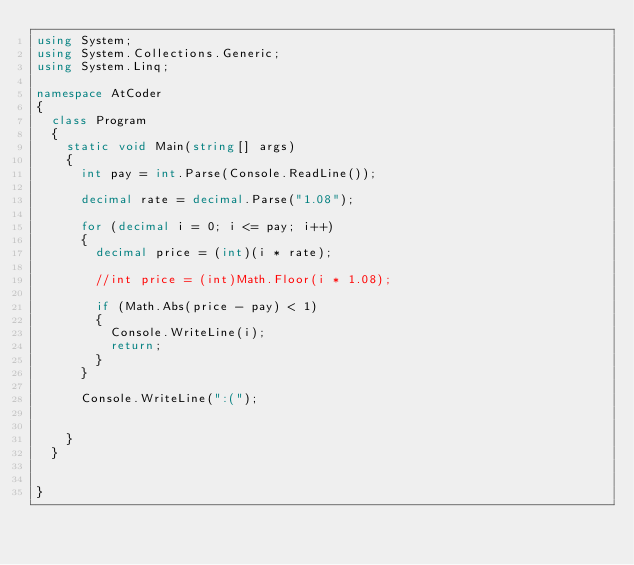<code> <loc_0><loc_0><loc_500><loc_500><_C#_>using System;
using System.Collections.Generic;
using System.Linq;

namespace AtCoder
{
	class Program
	{
		static void Main(string[] args)
		{
			int pay = int.Parse(Console.ReadLine());

			decimal rate = decimal.Parse("1.08");

			for (decimal i = 0; i <= pay; i++)
			{
				decimal price = (int)(i * rate);

				//int price = (int)Math.Floor(i * 1.08);

				if (Math.Abs(price - pay) < 1)
				{
					Console.WriteLine(i);
					return;
				}
			}

			Console.WriteLine(":(");


		}
	}


}
</code> 